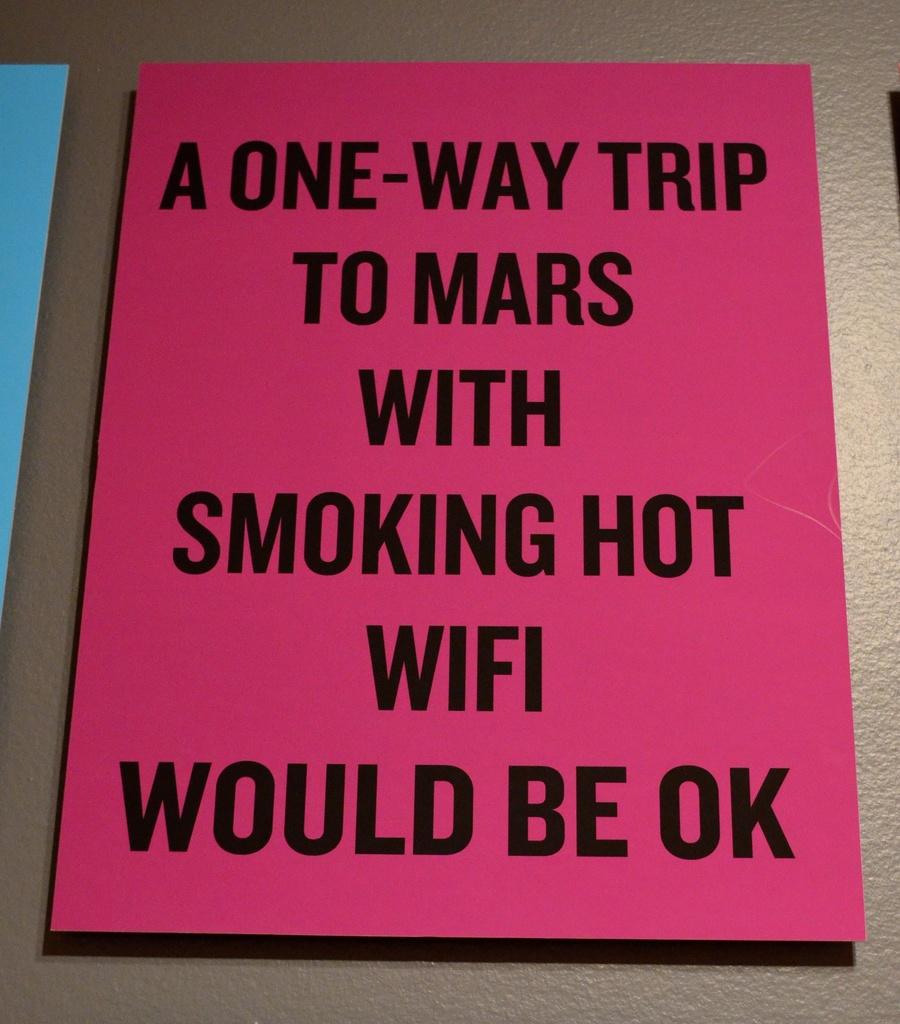What is the last word on this sign?
Your answer should be very brief. Ok. What is the planet mentioned?
Provide a short and direct response. Mars. 